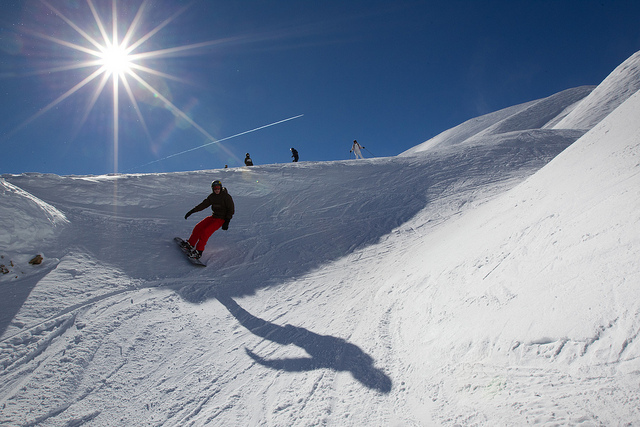What kind of gear would you need for snowboarding? For snowboarding, one would need a snowboard with appropriate bindings, snowboarding boots, a helmet for safety, goggles to protect the eyes from glare and wind, and suitable cold-weather clothing that is both water and wind-resistant to keep warm and dry. 